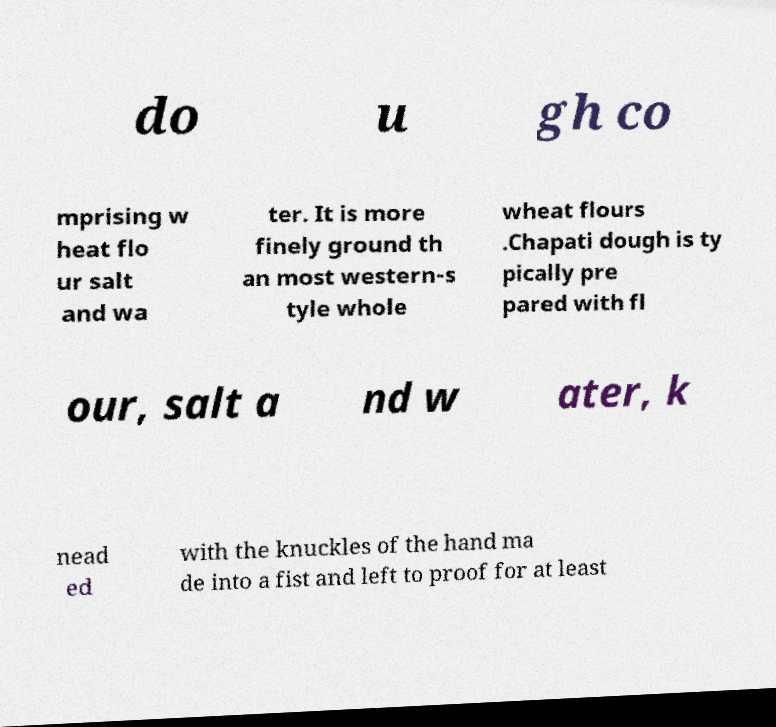Could you extract and type out the text from this image? do u gh co mprising w heat flo ur salt and wa ter. It is more finely ground th an most western-s tyle whole wheat flours .Chapati dough is ty pically pre pared with fl our, salt a nd w ater, k nead ed with the knuckles of the hand ma de into a fist and left to proof for at least 